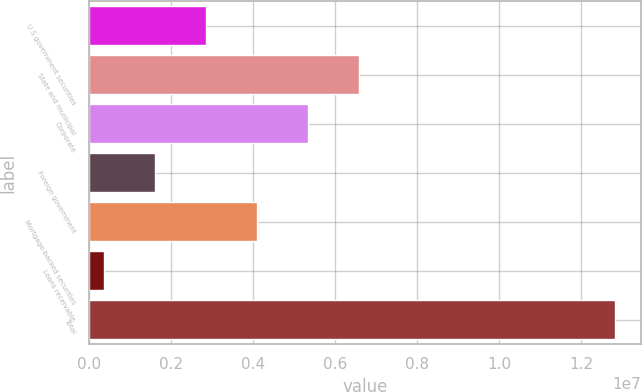<chart> <loc_0><loc_0><loc_500><loc_500><bar_chart><fcel>U S government securities<fcel>State and municipal<fcel>Corporate<fcel>Foreign government<fcel>Mortgage-backed securities<fcel>Loans receivable<fcel>Total<nl><fcel>2.84104e+06<fcel>6.58249e+06<fcel>5.33534e+06<fcel>1.59389e+06<fcel>4.08819e+06<fcel>346746<fcel>1.28182e+07<nl></chart> 